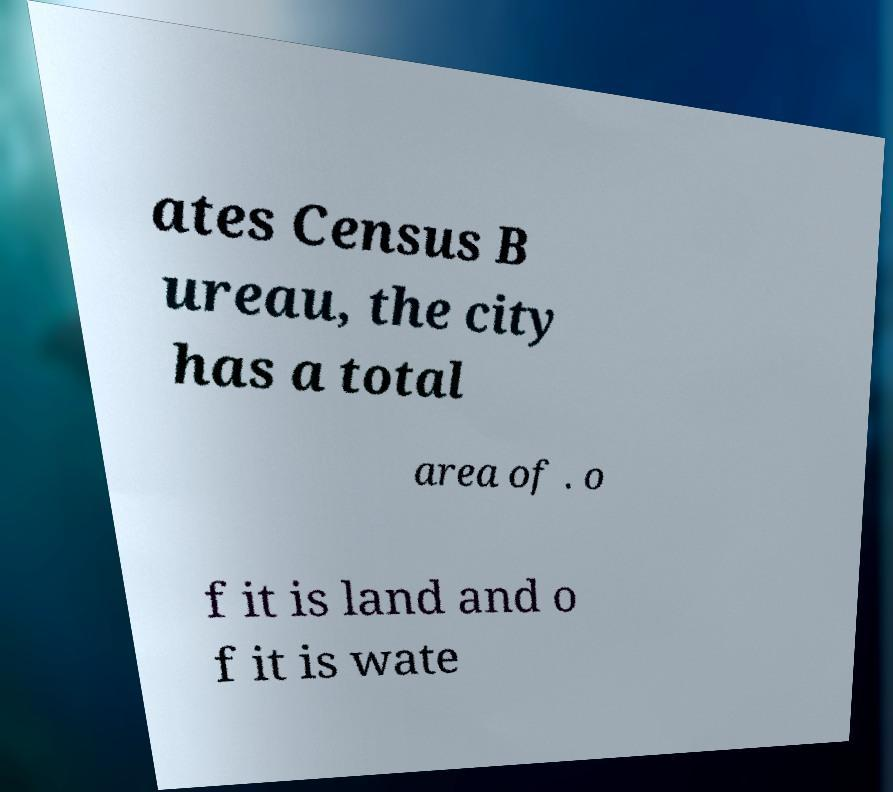There's text embedded in this image that I need extracted. Can you transcribe it verbatim? ates Census B ureau, the city has a total area of . o f it is land and o f it is wate 